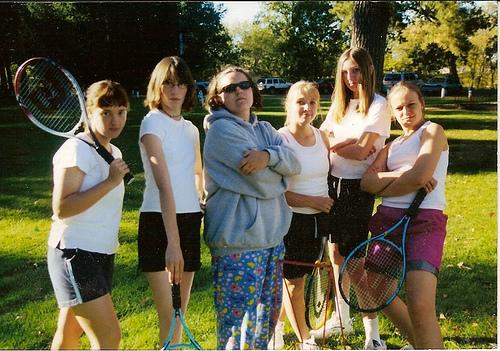Which sport do these women play?
Quick response, please. Tennis. Are these women smiling?
Give a very brief answer. No. How many women are in the group?
Short answer required. 6. 